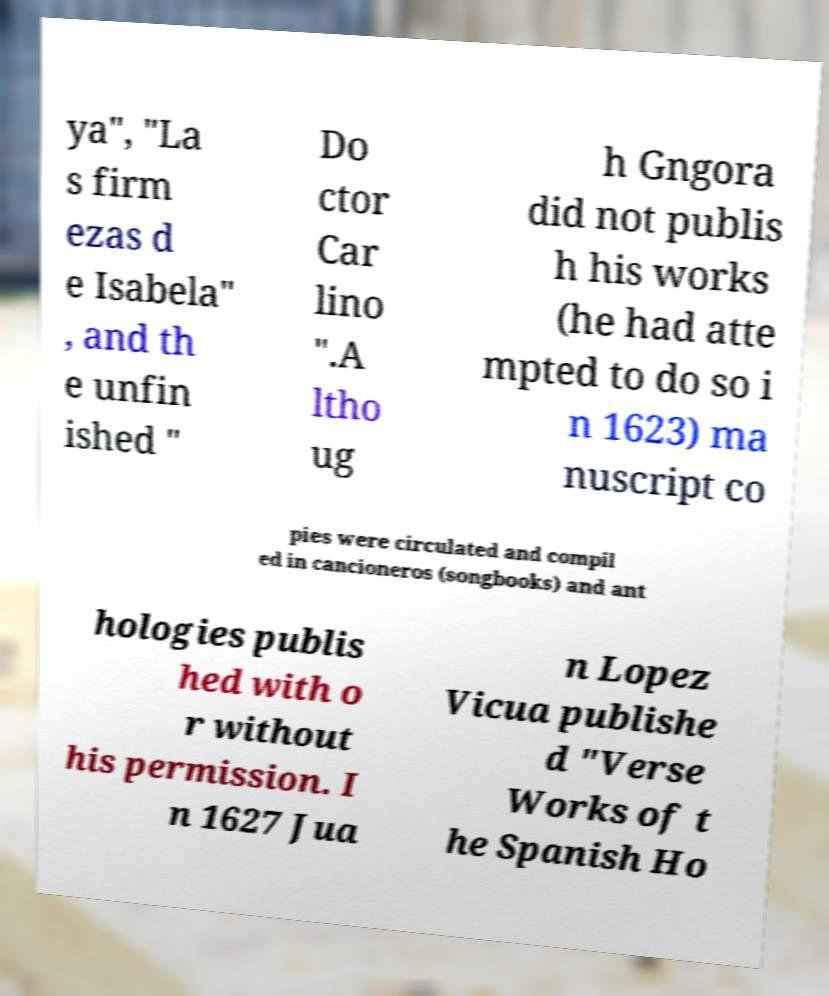There's text embedded in this image that I need extracted. Can you transcribe it verbatim? ya", "La s firm ezas d e Isabela" , and th e unfin ished " Do ctor Car lino ".A ltho ug h Gngora did not publis h his works (he had atte mpted to do so i n 1623) ma nuscript co pies were circulated and compil ed in cancioneros (songbooks) and ant hologies publis hed with o r without his permission. I n 1627 Jua n Lopez Vicua publishe d "Verse Works of t he Spanish Ho 